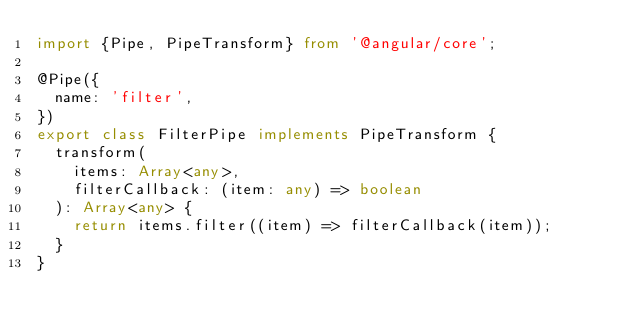Convert code to text. <code><loc_0><loc_0><loc_500><loc_500><_TypeScript_>import {Pipe, PipeTransform} from '@angular/core';

@Pipe({
  name: 'filter',
})
export class FilterPipe implements PipeTransform {
  transform(
    items: Array<any>,
    filterCallback: (item: any) => boolean
  ): Array<any> {
    return items.filter((item) => filterCallback(item));
  }
}
</code> 